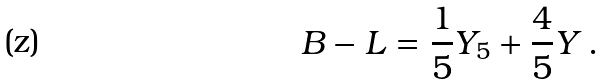Convert formula to latex. <formula><loc_0><loc_0><loc_500><loc_500>B - L = \frac { 1 } { 5 } Y _ { 5 } + \frac { 4 } { 5 } Y \, .</formula> 